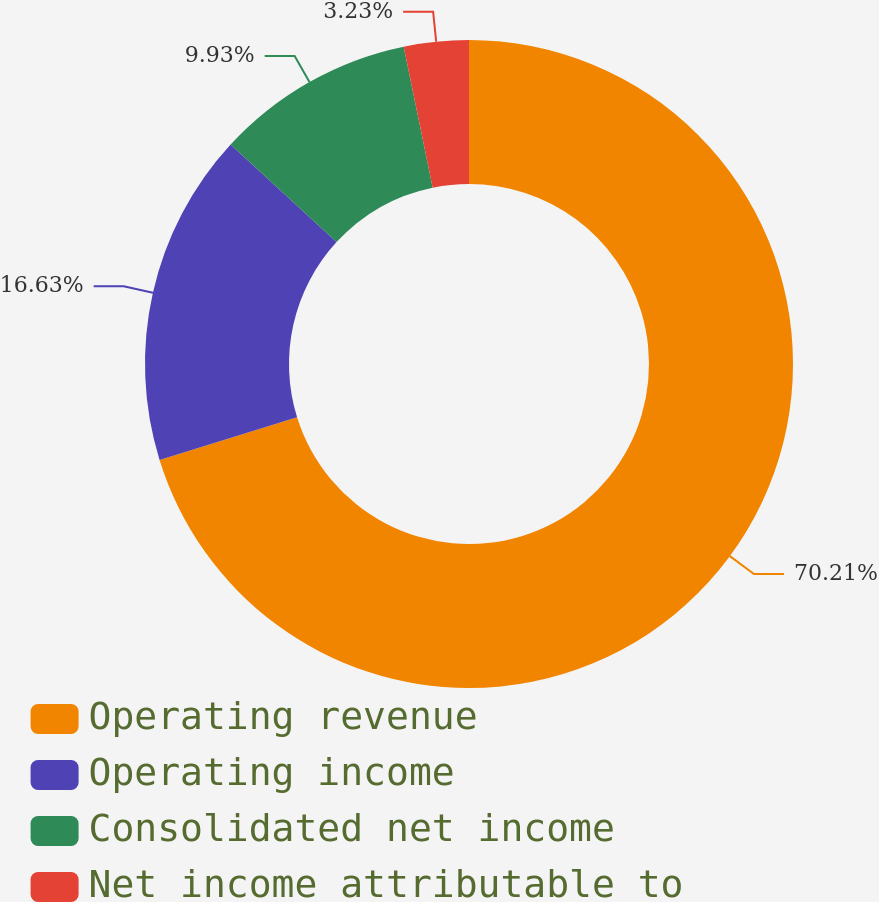Convert chart. <chart><loc_0><loc_0><loc_500><loc_500><pie_chart><fcel>Operating revenue<fcel>Operating income<fcel>Consolidated net income<fcel>Net income attributable to<nl><fcel>70.21%<fcel>16.63%<fcel>9.93%<fcel>3.23%<nl></chart> 